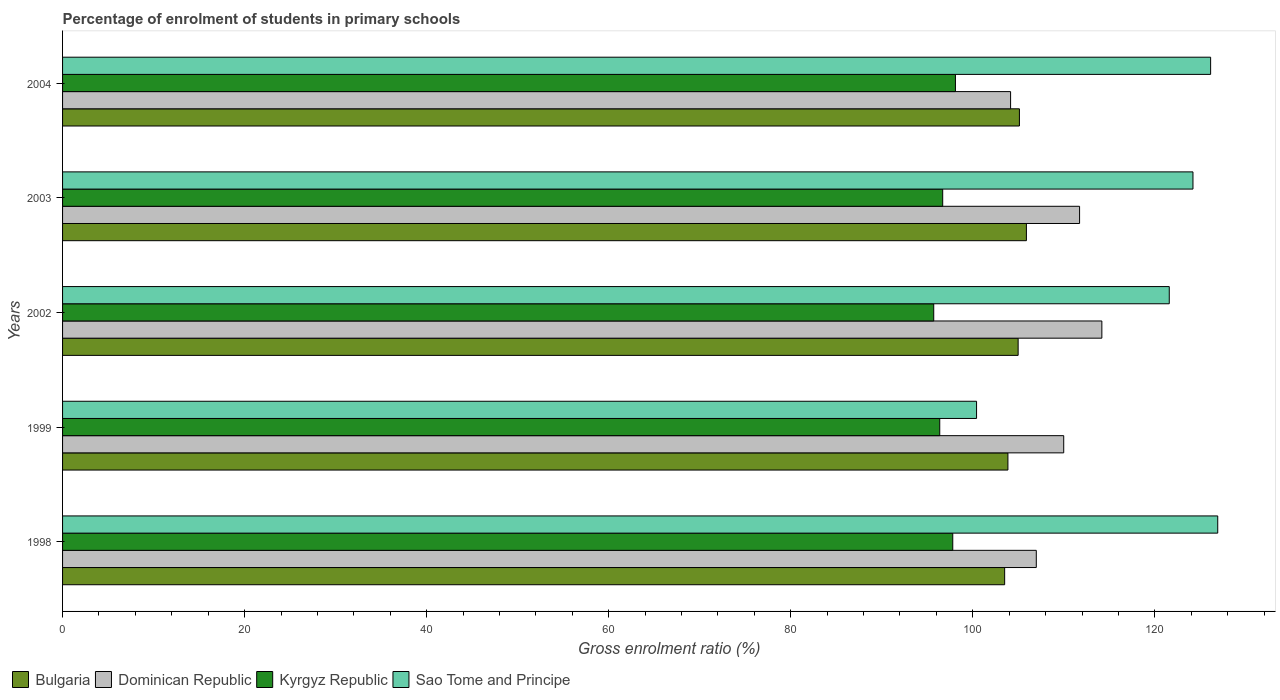Are the number of bars per tick equal to the number of legend labels?
Offer a very short reply. Yes. How many bars are there on the 5th tick from the bottom?
Keep it short and to the point. 4. What is the label of the 4th group of bars from the top?
Your response must be concise. 1999. In how many cases, is the number of bars for a given year not equal to the number of legend labels?
Offer a terse response. 0. What is the percentage of students enrolled in primary schools in Kyrgyz Republic in 1998?
Make the answer very short. 97.8. Across all years, what is the maximum percentage of students enrolled in primary schools in Sao Tome and Principe?
Give a very brief answer. 126.91. Across all years, what is the minimum percentage of students enrolled in primary schools in Dominican Republic?
Make the answer very short. 104.15. In which year was the percentage of students enrolled in primary schools in Sao Tome and Principe maximum?
Offer a very short reply. 1998. In which year was the percentage of students enrolled in primary schools in Dominican Republic minimum?
Offer a very short reply. 2004. What is the total percentage of students enrolled in primary schools in Sao Tome and Principe in the graph?
Your answer should be compact. 599.22. What is the difference between the percentage of students enrolled in primary schools in Dominican Republic in 1998 and that in 1999?
Offer a very short reply. -3.01. What is the difference between the percentage of students enrolled in primary schools in Bulgaria in 2004 and the percentage of students enrolled in primary schools in Dominican Republic in 1999?
Give a very brief answer. -4.87. What is the average percentage of students enrolled in primary schools in Sao Tome and Principe per year?
Keep it short and to the point. 119.84. In the year 1999, what is the difference between the percentage of students enrolled in primary schools in Dominican Republic and percentage of students enrolled in primary schools in Bulgaria?
Offer a terse response. 6.13. In how many years, is the percentage of students enrolled in primary schools in Kyrgyz Republic greater than 44 %?
Offer a very short reply. 5. What is the ratio of the percentage of students enrolled in primary schools in Bulgaria in 2002 to that in 2003?
Your answer should be very brief. 0.99. Is the difference between the percentage of students enrolled in primary schools in Dominican Republic in 2003 and 2004 greater than the difference between the percentage of students enrolled in primary schools in Bulgaria in 2003 and 2004?
Ensure brevity in your answer.  Yes. What is the difference between the highest and the second highest percentage of students enrolled in primary schools in Kyrgyz Republic?
Provide a short and direct response. 0.29. What is the difference between the highest and the lowest percentage of students enrolled in primary schools in Sao Tome and Principe?
Ensure brevity in your answer.  26.49. In how many years, is the percentage of students enrolled in primary schools in Kyrgyz Republic greater than the average percentage of students enrolled in primary schools in Kyrgyz Republic taken over all years?
Provide a succinct answer. 2. Is the sum of the percentage of students enrolled in primary schools in Dominican Republic in 1998 and 1999 greater than the maximum percentage of students enrolled in primary schools in Sao Tome and Principe across all years?
Offer a terse response. Yes. What does the 1st bar from the top in 2004 represents?
Keep it short and to the point. Sao Tome and Principe. What does the 3rd bar from the bottom in 2003 represents?
Provide a succinct answer. Kyrgyz Republic. Are all the bars in the graph horizontal?
Give a very brief answer. Yes. How many years are there in the graph?
Your response must be concise. 5. What is the difference between two consecutive major ticks on the X-axis?
Your answer should be very brief. 20. Does the graph contain grids?
Provide a succinct answer. No. Where does the legend appear in the graph?
Keep it short and to the point. Bottom left. How many legend labels are there?
Make the answer very short. 4. What is the title of the graph?
Offer a terse response. Percentage of enrolment of students in primary schools. Does "Guinea" appear as one of the legend labels in the graph?
Give a very brief answer. No. What is the Gross enrolment ratio (%) of Bulgaria in 1998?
Keep it short and to the point. 103.5. What is the Gross enrolment ratio (%) in Dominican Republic in 1998?
Make the answer very short. 106.98. What is the Gross enrolment ratio (%) in Kyrgyz Republic in 1998?
Your answer should be very brief. 97.8. What is the Gross enrolment ratio (%) of Sao Tome and Principe in 1998?
Your answer should be compact. 126.91. What is the Gross enrolment ratio (%) in Bulgaria in 1999?
Offer a very short reply. 103.86. What is the Gross enrolment ratio (%) in Dominican Republic in 1999?
Your response must be concise. 109.99. What is the Gross enrolment ratio (%) of Kyrgyz Republic in 1999?
Give a very brief answer. 96.37. What is the Gross enrolment ratio (%) of Sao Tome and Principe in 1999?
Keep it short and to the point. 100.41. What is the Gross enrolment ratio (%) in Bulgaria in 2002?
Offer a very short reply. 104.98. What is the Gross enrolment ratio (%) in Dominican Republic in 2002?
Your answer should be very brief. 114.18. What is the Gross enrolment ratio (%) in Kyrgyz Republic in 2002?
Your response must be concise. 95.71. What is the Gross enrolment ratio (%) in Sao Tome and Principe in 2002?
Give a very brief answer. 121.58. What is the Gross enrolment ratio (%) in Bulgaria in 2003?
Make the answer very short. 105.89. What is the Gross enrolment ratio (%) in Dominican Republic in 2003?
Keep it short and to the point. 111.73. What is the Gross enrolment ratio (%) of Kyrgyz Republic in 2003?
Keep it short and to the point. 96.69. What is the Gross enrolment ratio (%) in Sao Tome and Principe in 2003?
Give a very brief answer. 124.19. What is the Gross enrolment ratio (%) of Bulgaria in 2004?
Provide a short and direct response. 105.12. What is the Gross enrolment ratio (%) in Dominican Republic in 2004?
Your response must be concise. 104.15. What is the Gross enrolment ratio (%) in Kyrgyz Republic in 2004?
Ensure brevity in your answer.  98.09. What is the Gross enrolment ratio (%) in Sao Tome and Principe in 2004?
Your answer should be very brief. 126.13. Across all years, what is the maximum Gross enrolment ratio (%) of Bulgaria?
Offer a very short reply. 105.89. Across all years, what is the maximum Gross enrolment ratio (%) in Dominican Republic?
Provide a short and direct response. 114.18. Across all years, what is the maximum Gross enrolment ratio (%) of Kyrgyz Republic?
Your response must be concise. 98.09. Across all years, what is the maximum Gross enrolment ratio (%) in Sao Tome and Principe?
Ensure brevity in your answer.  126.91. Across all years, what is the minimum Gross enrolment ratio (%) in Bulgaria?
Offer a terse response. 103.5. Across all years, what is the minimum Gross enrolment ratio (%) in Dominican Republic?
Provide a succinct answer. 104.15. Across all years, what is the minimum Gross enrolment ratio (%) in Kyrgyz Republic?
Give a very brief answer. 95.71. Across all years, what is the minimum Gross enrolment ratio (%) of Sao Tome and Principe?
Give a very brief answer. 100.41. What is the total Gross enrolment ratio (%) in Bulgaria in the graph?
Your answer should be compact. 523.35. What is the total Gross enrolment ratio (%) in Dominican Republic in the graph?
Ensure brevity in your answer.  547.03. What is the total Gross enrolment ratio (%) in Kyrgyz Republic in the graph?
Offer a terse response. 484.66. What is the total Gross enrolment ratio (%) of Sao Tome and Principe in the graph?
Give a very brief answer. 599.22. What is the difference between the Gross enrolment ratio (%) of Bulgaria in 1998 and that in 1999?
Keep it short and to the point. -0.36. What is the difference between the Gross enrolment ratio (%) in Dominican Republic in 1998 and that in 1999?
Give a very brief answer. -3.01. What is the difference between the Gross enrolment ratio (%) of Kyrgyz Republic in 1998 and that in 1999?
Give a very brief answer. 1.43. What is the difference between the Gross enrolment ratio (%) in Sao Tome and Principe in 1998 and that in 1999?
Ensure brevity in your answer.  26.5. What is the difference between the Gross enrolment ratio (%) of Bulgaria in 1998 and that in 2002?
Your answer should be very brief. -1.48. What is the difference between the Gross enrolment ratio (%) of Dominican Republic in 1998 and that in 2002?
Your answer should be very brief. -7.2. What is the difference between the Gross enrolment ratio (%) of Kyrgyz Republic in 1998 and that in 2002?
Your answer should be compact. 2.09. What is the difference between the Gross enrolment ratio (%) of Sao Tome and Principe in 1998 and that in 2002?
Offer a very short reply. 5.33. What is the difference between the Gross enrolment ratio (%) of Bulgaria in 1998 and that in 2003?
Make the answer very short. -2.39. What is the difference between the Gross enrolment ratio (%) of Dominican Republic in 1998 and that in 2003?
Provide a succinct answer. -4.75. What is the difference between the Gross enrolment ratio (%) in Kyrgyz Republic in 1998 and that in 2003?
Provide a succinct answer. 1.11. What is the difference between the Gross enrolment ratio (%) in Sao Tome and Principe in 1998 and that in 2003?
Offer a terse response. 2.72. What is the difference between the Gross enrolment ratio (%) of Bulgaria in 1998 and that in 2004?
Offer a terse response. -1.62. What is the difference between the Gross enrolment ratio (%) in Dominican Republic in 1998 and that in 2004?
Ensure brevity in your answer.  2.82. What is the difference between the Gross enrolment ratio (%) in Kyrgyz Republic in 1998 and that in 2004?
Make the answer very short. -0.29. What is the difference between the Gross enrolment ratio (%) of Sao Tome and Principe in 1998 and that in 2004?
Provide a short and direct response. 0.78. What is the difference between the Gross enrolment ratio (%) of Bulgaria in 1999 and that in 2002?
Your answer should be compact. -1.12. What is the difference between the Gross enrolment ratio (%) of Dominican Republic in 1999 and that in 2002?
Offer a terse response. -4.19. What is the difference between the Gross enrolment ratio (%) in Kyrgyz Republic in 1999 and that in 2002?
Make the answer very short. 0.66. What is the difference between the Gross enrolment ratio (%) in Sao Tome and Principe in 1999 and that in 2002?
Your answer should be very brief. -21.17. What is the difference between the Gross enrolment ratio (%) in Bulgaria in 1999 and that in 2003?
Offer a very short reply. -2.03. What is the difference between the Gross enrolment ratio (%) of Dominican Republic in 1999 and that in 2003?
Your answer should be compact. -1.74. What is the difference between the Gross enrolment ratio (%) in Kyrgyz Republic in 1999 and that in 2003?
Provide a short and direct response. -0.32. What is the difference between the Gross enrolment ratio (%) of Sao Tome and Principe in 1999 and that in 2003?
Your response must be concise. -23.77. What is the difference between the Gross enrolment ratio (%) in Bulgaria in 1999 and that in 2004?
Offer a terse response. -1.26. What is the difference between the Gross enrolment ratio (%) of Dominican Republic in 1999 and that in 2004?
Provide a succinct answer. 5.84. What is the difference between the Gross enrolment ratio (%) of Kyrgyz Republic in 1999 and that in 2004?
Your answer should be compact. -1.72. What is the difference between the Gross enrolment ratio (%) in Sao Tome and Principe in 1999 and that in 2004?
Your answer should be very brief. -25.71. What is the difference between the Gross enrolment ratio (%) in Bulgaria in 2002 and that in 2003?
Your response must be concise. -0.91. What is the difference between the Gross enrolment ratio (%) of Dominican Republic in 2002 and that in 2003?
Provide a short and direct response. 2.45. What is the difference between the Gross enrolment ratio (%) in Kyrgyz Republic in 2002 and that in 2003?
Ensure brevity in your answer.  -0.99. What is the difference between the Gross enrolment ratio (%) of Sao Tome and Principe in 2002 and that in 2003?
Offer a terse response. -2.61. What is the difference between the Gross enrolment ratio (%) in Bulgaria in 2002 and that in 2004?
Your answer should be very brief. -0.14. What is the difference between the Gross enrolment ratio (%) in Dominican Republic in 2002 and that in 2004?
Provide a short and direct response. 10.03. What is the difference between the Gross enrolment ratio (%) in Kyrgyz Republic in 2002 and that in 2004?
Ensure brevity in your answer.  -2.39. What is the difference between the Gross enrolment ratio (%) of Sao Tome and Principe in 2002 and that in 2004?
Make the answer very short. -4.55. What is the difference between the Gross enrolment ratio (%) in Bulgaria in 2003 and that in 2004?
Give a very brief answer. 0.77. What is the difference between the Gross enrolment ratio (%) in Dominican Republic in 2003 and that in 2004?
Provide a succinct answer. 7.58. What is the difference between the Gross enrolment ratio (%) of Kyrgyz Republic in 2003 and that in 2004?
Provide a succinct answer. -1.4. What is the difference between the Gross enrolment ratio (%) in Sao Tome and Principe in 2003 and that in 2004?
Your response must be concise. -1.94. What is the difference between the Gross enrolment ratio (%) in Bulgaria in 1998 and the Gross enrolment ratio (%) in Dominican Republic in 1999?
Provide a succinct answer. -6.49. What is the difference between the Gross enrolment ratio (%) in Bulgaria in 1998 and the Gross enrolment ratio (%) in Kyrgyz Republic in 1999?
Make the answer very short. 7.13. What is the difference between the Gross enrolment ratio (%) of Bulgaria in 1998 and the Gross enrolment ratio (%) of Sao Tome and Principe in 1999?
Provide a short and direct response. 3.09. What is the difference between the Gross enrolment ratio (%) of Dominican Republic in 1998 and the Gross enrolment ratio (%) of Kyrgyz Republic in 1999?
Keep it short and to the point. 10.61. What is the difference between the Gross enrolment ratio (%) in Dominican Republic in 1998 and the Gross enrolment ratio (%) in Sao Tome and Principe in 1999?
Your answer should be very brief. 6.56. What is the difference between the Gross enrolment ratio (%) in Kyrgyz Republic in 1998 and the Gross enrolment ratio (%) in Sao Tome and Principe in 1999?
Your answer should be very brief. -2.61. What is the difference between the Gross enrolment ratio (%) of Bulgaria in 1998 and the Gross enrolment ratio (%) of Dominican Republic in 2002?
Keep it short and to the point. -10.68. What is the difference between the Gross enrolment ratio (%) in Bulgaria in 1998 and the Gross enrolment ratio (%) in Kyrgyz Republic in 2002?
Offer a very short reply. 7.79. What is the difference between the Gross enrolment ratio (%) in Bulgaria in 1998 and the Gross enrolment ratio (%) in Sao Tome and Principe in 2002?
Keep it short and to the point. -18.08. What is the difference between the Gross enrolment ratio (%) of Dominican Republic in 1998 and the Gross enrolment ratio (%) of Kyrgyz Republic in 2002?
Make the answer very short. 11.27. What is the difference between the Gross enrolment ratio (%) in Dominican Republic in 1998 and the Gross enrolment ratio (%) in Sao Tome and Principe in 2002?
Provide a succinct answer. -14.61. What is the difference between the Gross enrolment ratio (%) in Kyrgyz Republic in 1998 and the Gross enrolment ratio (%) in Sao Tome and Principe in 2002?
Keep it short and to the point. -23.78. What is the difference between the Gross enrolment ratio (%) in Bulgaria in 1998 and the Gross enrolment ratio (%) in Dominican Republic in 2003?
Provide a succinct answer. -8.23. What is the difference between the Gross enrolment ratio (%) in Bulgaria in 1998 and the Gross enrolment ratio (%) in Kyrgyz Republic in 2003?
Provide a succinct answer. 6.81. What is the difference between the Gross enrolment ratio (%) of Bulgaria in 1998 and the Gross enrolment ratio (%) of Sao Tome and Principe in 2003?
Make the answer very short. -20.69. What is the difference between the Gross enrolment ratio (%) of Dominican Republic in 1998 and the Gross enrolment ratio (%) of Kyrgyz Republic in 2003?
Make the answer very short. 10.28. What is the difference between the Gross enrolment ratio (%) of Dominican Republic in 1998 and the Gross enrolment ratio (%) of Sao Tome and Principe in 2003?
Provide a succinct answer. -17.21. What is the difference between the Gross enrolment ratio (%) of Kyrgyz Republic in 1998 and the Gross enrolment ratio (%) of Sao Tome and Principe in 2003?
Your answer should be very brief. -26.39. What is the difference between the Gross enrolment ratio (%) of Bulgaria in 1998 and the Gross enrolment ratio (%) of Dominican Republic in 2004?
Your answer should be very brief. -0.65. What is the difference between the Gross enrolment ratio (%) of Bulgaria in 1998 and the Gross enrolment ratio (%) of Kyrgyz Republic in 2004?
Make the answer very short. 5.41. What is the difference between the Gross enrolment ratio (%) in Bulgaria in 1998 and the Gross enrolment ratio (%) in Sao Tome and Principe in 2004?
Offer a very short reply. -22.63. What is the difference between the Gross enrolment ratio (%) in Dominican Republic in 1998 and the Gross enrolment ratio (%) in Kyrgyz Republic in 2004?
Provide a short and direct response. 8.88. What is the difference between the Gross enrolment ratio (%) of Dominican Republic in 1998 and the Gross enrolment ratio (%) of Sao Tome and Principe in 2004?
Provide a short and direct response. -19.15. What is the difference between the Gross enrolment ratio (%) in Kyrgyz Republic in 1998 and the Gross enrolment ratio (%) in Sao Tome and Principe in 2004?
Your response must be concise. -28.33. What is the difference between the Gross enrolment ratio (%) in Bulgaria in 1999 and the Gross enrolment ratio (%) in Dominican Republic in 2002?
Ensure brevity in your answer.  -10.32. What is the difference between the Gross enrolment ratio (%) in Bulgaria in 1999 and the Gross enrolment ratio (%) in Kyrgyz Republic in 2002?
Offer a terse response. 8.15. What is the difference between the Gross enrolment ratio (%) of Bulgaria in 1999 and the Gross enrolment ratio (%) of Sao Tome and Principe in 2002?
Your answer should be compact. -17.72. What is the difference between the Gross enrolment ratio (%) in Dominican Republic in 1999 and the Gross enrolment ratio (%) in Kyrgyz Republic in 2002?
Give a very brief answer. 14.28. What is the difference between the Gross enrolment ratio (%) in Dominican Republic in 1999 and the Gross enrolment ratio (%) in Sao Tome and Principe in 2002?
Offer a very short reply. -11.6. What is the difference between the Gross enrolment ratio (%) in Kyrgyz Republic in 1999 and the Gross enrolment ratio (%) in Sao Tome and Principe in 2002?
Provide a short and direct response. -25.21. What is the difference between the Gross enrolment ratio (%) of Bulgaria in 1999 and the Gross enrolment ratio (%) of Dominican Republic in 2003?
Keep it short and to the point. -7.87. What is the difference between the Gross enrolment ratio (%) of Bulgaria in 1999 and the Gross enrolment ratio (%) of Kyrgyz Republic in 2003?
Provide a short and direct response. 7.17. What is the difference between the Gross enrolment ratio (%) of Bulgaria in 1999 and the Gross enrolment ratio (%) of Sao Tome and Principe in 2003?
Your answer should be compact. -20.33. What is the difference between the Gross enrolment ratio (%) of Dominican Republic in 1999 and the Gross enrolment ratio (%) of Kyrgyz Republic in 2003?
Keep it short and to the point. 13.29. What is the difference between the Gross enrolment ratio (%) of Dominican Republic in 1999 and the Gross enrolment ratio (%) of Sao Tome and Principe in 2003?
Your response must be concise. -14.2. What is the difference between the Gross enrolment ratio (%) of Kyrgyz Republic in 1999 and the Gross enrolment ratio (%) of Sao Tome and Principe in 2003?
Make the answer very short. -27.82. What is the difference between the Gross enrolment ratio (%) of Bulgaria in 1999 and the Gross enrolment ratio (%) of Dominican Republic in 2004?
Keep it short and to the point. -0.29. What is the difference between the Gross enrolment ratio (%) of Bulgaria in 1999 and the Gross enrolment ratio (%) of Kyrgyz Republic in 2004?
Make the answer very short. 5.77. What is the difference between the Gross enrolment ratio (%) of Bulgaria in 1999 and the Gross enrolment ratio (%) of Sao Tome and Principe in 2004?
Provide a short and direct response. -22.27. What is the difference between the Gross enrolment ratio (%) of Dominican Republic in 1999 and the Gross enrolment ratio (%) of Kyrgyz Republic in 2004?
Keep it short and to the point. 11.89. What is the difference between the Gross enrolment ratio (%) of Dominican Republic in 1999 and the Gross enrolment ratio (%) of Sao Tome and Principe in 2004?
Your response must be concise. -16.14. What is the difference between the Gross enrolment ratio (%) in Kyrgyz Republic in 1999 and the Gross enrolment ratio (%) in Sao Tome and Principe in 2004?
Provide a short and direct response. -29.76. What is the difference between the Gross enrolment ratio (%) in Bulgaria in 2002 and the Gross enrolment ratio (%) in Dominican Republic in 2003?
Your answer should be very brief. -6.75. What is the difference between the Gross enrolment ratio (%) of Bulgaria in 2002 and the Gross enrolment ratio (%) of Kyrgyz Republic in 2003?
Keep it short and to the point. 8.29. What is the difference between the Gross enrolment ratio (%) of Bulgaria in 2002 and the Gross enrolment ratio (%) of Sao Tome and Principe in 2003?
Provide a succinct answer. -19.21. What is the difference between the Gross enrolment ratio (%) of Dominican Republic in 2002 and the Gross enrolment ratio (%) of Kyrgyz Republic in 2003?
Keep it short and to the point. 17.49. What is the difference between the Gross enrolment ratio (%) of Dominican Republic in 2002 and the Gross enrolment ratio (%) of Sao Tome and Principe in 2003?
Your answer should be compact. -10.01. What is the difference between the Gross enrolment ratio (%) in Kyrgyz Republic in 2002 and the Gross enrolment ratio (%) in Sao Tome and Principe in 2003?
Offer a terse response. -28.48. What is the difference between the Gross enrolment ratio (%) in Bulgaria in 2002 and the Gross enrolment ratio (%) in Dominican Republic in 2004?
Offer a very short reply. 0.83. What is the difference between the Gross enrolment ratio (%) of Bulgaria in 2002 and the Gross enrolment ratio (%) of Kyrgyz Republic in 2004?
Offer a very short reply. 6.89. What is the difference between the Gross enrolment ratio (%) of Bulgaria in 2002 and the Gross enrolment ratio (%) of Sao Tome and Principe in 2004?
Give a very brief answer. -21.15. What is the difference between the Gross enrolment ratio (%) in Dominican Republic in 2002 and the Gross enrolment ratio (%) in Kyrgyz Republic in 2004?
Your answer should be compact. 16.09. What is the difference between the Gross enrolment ratio (%) of Dominican Republic in 2002 and the Gross enrolment ratio (%) of Sao Tome and Principe in 2004?
Keep it short and to the point. -11.95. What is the difference between the Gross enrolment ratio (%) in Kyrgyz Republic in 2002 and the Gross enrolment ratio (%) in Sao Tome and Principe in 2004?
Your answer should be compact. -30.42. What is the difference between the Gross enrolment ratio (%) in Bulgaria in 2003 and the Gross enrolment ratio (%) in Dominican Republic in 2004?
Provide a succinct answer. 1.74. What is the difference between the Gross enrolment ratio (%) in Bulgaria in 2003 and the Gross enrolment ratio (%) in Kyrgyz Republic in 2004?
Keep it short and to the point. 7.8. What is the difference between the Gross enrolment ratio (%) in Bulgaria in 2003 and the Gross enrolment ratio (%) in Sao Tome and Principe in 2004?
Give a very brief answer. -20.24. What is the difference between the Gross enrolment ratio (%) of Dominican Republic in 2003 and the Gross enrolment ratio (%) of Kyrgyz Republic in 2004?
Make the answer very short. 13.64. What is the difference between the Gross enrolment ratio (%) of Dominican Republic in 2003 and the Gross enrolment ratio (%) of Sao Tome and Principe in 2004?
Provide a succinct answer. -14.4. What is the difference between the Gross enrolment ratio (%) of Kyrgyz Republic in 2003 and the Gross enrolment ratio (%) of Sao Tome and Principe in 2004?
Your response must be concise. -29.44. What is the average Gross enrolment ratio (%) of Bulgaria per year?
Make the answer very short. 104.67. What is the average Gross enrolment ratio (%) in Dominican Republic per year?
Your answer should be compact. 109.41. What is the average Gross enrolment ratio (%) of Kyrgyz Republic per year?
Keep it short and to the point. 96.93. What is the average Gross enrolment ratio (%) of Sao Tome and Principe per year?
Provide a short and direct response. 119.84. In the year 1998, what is the difference between the Gross enrolment ratio (%) of Bulgaria and Gross enrolment ratio (%) of Dominican Republic?
Provide a short and direct response. -3.48. In the year 1998, what is the difference between the Gross enrolment ratio (%) of Bulgaria and Gross enrolment ratio (%) of Kyrgyz Republic?
Your answer should be very brief. 5.7. In the year 1998, what is the difference between the Gross enrolment ratio (%) of Bulgaria and Gross enrolment ratio (%) of Sao Tome and Principe?
Your response must be concise. -23.41. In the year 1998, what is the difference between the Gross enrolment ratio (%) in Dominican Republic and Gross enrolment ratio (%) in Kyrgyz Republic?
Offer a very short reply. 9.18. In the year 1998, what is the difference between the Gross enrolment ratio (%) of Dominican Republic and Gross enrolment ratio (%) of Sao Tome and Principe?
Provide a short and direct response. -19.93. In the year 1998, what is the difference between the Gross enrolment ratio (%) in Kyrgyz Republic and Gross enrolment ratio (%) in Sao Tome and Principe?
Provide a succinct answer. -29.11. In the year 1999, what is the difference between the Gross enrolment ratio (%) of Bulgaria and Gross enrolment ratio (%) of Dominican Republic?
Make the answer very short. -6.13. In the year 1999, what is the difference between the Gross enrolment ratio (%) of Bulgaria and Gross enrolment ratio (%) of Kyrgyz Republic?
Provide a short and direct response. 7.49. In the year 1999, what is the difference between the Gross enrolment ratio (%) of Bulgaria and Gross enrolment ratio (%) of Sao Tome and Principe?
Ensure brevity in your answer.  3.45. In the year 1999, what is the difference between the Gross enrolment ratio (%) of Dominican Republic and Gross enrolment ratio (%) of Kyrgyz Republic?
Ensure brevity in your answer.  13.62. In the year 1999, what is the difference between the Gross enrolment ratio (%) in Dominican Republic and Gross enrolment ratio (%) in Sao Tome and Principe?
Make the answer very short. 9.57. In the year 1999, what is the difference between the Gross enrolment ratio (%) of Kyrgyz Republic and Gross enrolment ratio (%) of Sao Tome and Principe?
Offer a terse response. -4.04. In the year 2002, what is the difference between the Gross enrolment ratio (%) in Bulgaria and Gross enrolment ratio (%) in Dominican Republic?
Ensure brevity in your answer.  -9.2. In the year 2002, what is the difference between the Gross enrolment ratio (%) in Bulgaria and Gross enrolment ratio (%) in Kyrgyz Republic?
Your answer should be compact. 9.27. In the year 2002, what is the difference between the Gross enrolment ratio (%) of Bulgaria and Gross enrolment ratio (%) of Sao Tome and Principe?
Provide a short and direct response. -16.6. In the year 2002, what is the difference between the Gross enrolment ratio (%) of Dominican Republic and Gross enrolment ratio (%) of Kyrgyz Republic?
Give a very brief answer. 18.47. In the year 2002, what is the difference between the Gross enrolment ratio (%) of Dominican Republic and Gross enrolment ratio (%) of Sao Tome and Principe?
Offer a terse response. -7.4. In the year 2002, what is the difference between the Gross enrolment ratio (%) of Kyrgyz Republic and Gross enrolment ratio (%) of Sao Tome and Principe?
Offer a terse response. -25.88. In the year 2003, what is the difference between the Gross enrolment ratio (%) of Bulgaria and Gross enrolment ratio (%) of Dominican Republic?
Provide a short and direct response. -5.84. In the year 2003, what is the difference between the Gross enrolment ratio (%) in Bulgaria and Gross enrolment ratio (%) in Kyrgyz Republic?
Offer a terse response. 9.2. In the year 2003, what is the difference between the Gross enrolment ratio (%) of Bulgaria and Gross enrolment ratio (%) of Sao Tome and Principe?
Your answer should be very brief. -18.3. In the year 2003, what is the difference between the Gross enrolment ratio (%) in Dominican Republic and Gross enrolment ratio (%) in Kyrgyz Republic?
Ensure brevity in your answer.  15.04. In the year 2003, what is the difference between the Gross enrolment ratio (%) in Dominican Republic and Gross enrolment ratio (%) in Sao Tome and Principe?
Offer a very short reply. -12.46. In the year 2003, what is the difference between the Gross enrolment ratio (%) of Kyrgyz Republic and Gross enrolment ratio (%) of Sao Tome and Principe?
Keep it short and to the point. -27.5. In the year 2004, what is the difference between the Gross enrolment ratio (%) of Bulgaria and Gross enrolment ratio (%) of Dominican Republic?
Ensure brevity in your answer.  0.97. In the year 2004, what is the difference between the Gross enrolment ratio (%) in Bulgaria and Gross enrolment ratio (%) in Kyrgyz Republic?
Provide a succinct answer. 7.03. In the year 2004, what is the difference between the Gross enrolment ratio (%) in Bulgaria and Gross enrolment ratio (%) in Sao Tome and Principe?
Make the answer very short. -21.01. In the year 2004, what is the difference between the Gross enrolment ratio (%) in Dominican Republic and Gross enrolment ratio (%) in Kyrgyz Republic?
Your response must be concise. 6.06. In the year 2004, what is the difference between the Gross enrolment ratio (%) of Dominican Republic and Gross enrolment ratio (%) of Sao Tome and Principe?
Your answer should be compact. -21.98. In the year 2004, what is the difference between the Gross enrolment ratio (%) of Kyrgyz Republic and Gross enrolment ratio (%) of Sao Tome and Principe?
Ensure brevity in your answer.  -28.04. What is the ratio of the Gross enrolment ratio (%) of Bulgaria in 1998 to that in 1999?
Offer a terse response. 1. What is the ratio of the Gross enrolment ratio (%) of Dominican Republic in 1998 to that in 1999?
Keep it short and to the point. 0.97. What is the ratio of the Gross enrolment ratio (%) in Kyrgyz Republic in 1998 to that in 1999?
Your answer should be compact. 1.01. What is the ratio of the Gross enrolment ratio (%) in Sao Tome and Principe in 1998 to that in 1999?
Ensure brevity in your answer.  1.26. What is the ratio of the Gross enrolment ratio (%) of Bulgaria in 1998 to that in 2002?
Your answer should be compact. 0.99. What is the ratio of the Gross enrolment ratio (%) of Dominican Republic in 1998 to that in 2002?
Give a very brief answer. 0.94. What is the ratio of the Gross enrolment ratio (%) in Kyrgyz Republic in 1998 to that in 2002?
Provide a short and direct response. 1.02. What is the ratio of the Gross enrolment ratio (%) in Sao Tome and Principe in 1998 to that in 2002?
Provide a short and direct response. 1.04. What is the ratio of the Gross enrolment ratio (%) of Bulgaria in 1998 to that in 2003?
Offer a terse response. 0.98. What is the ratio of the Gross enrolment ratio (%) of Dominican Republic in 1998 to that in 2003?
Provide a short and direct response. 0.96. What is the ratio of the Gross enrolment ratio (%) of Kyrgyz Republic in 1998 to that in 2003?
Your response must be concise. 1.01. What is the ratio of the Gross enrolment ratio (%) of Sao Tome and Principe in 1998 to that in 2003?
Make the answer very short. 1.02. What is the ratio of the Gross enrolment ratio (%) of Bulgaria in 1998 to that in 2004?
Ensure brevity in your answer.  0.98. What is the ratio of the Gross enrolment ratio (%) in Dominican Republic in 1998 to that in 2004?
Give a very brief answer. 1.03. What is the ratio of the Gross enrolment ratio (%) in Kyrgyz Republic in 1998 to that in 2004?
Keep it short and to the point. 1. What is the ratio of the Gross enrolment ratio (%) in Sao Tome and Principe in 1998 to that in 2004?
Offer a terse response. 1.01. What is the ratio of the Gross enrolment ratio (%) of Bulgaria in 1999 to that in 2002?
Keep it short and to the point. 0.99. What is the ratio of the Gross enrolment ratio (%) of Dominican Republic in 1999 to that in 2002?
Keep it short and to the point. 0.96. What is the ratio of the Gross enrolment ratio (%) in Sao Tome and Principe in 1999 to that in 2002?
Keep it short and to the point. 0.83. What is the ratio of the Gross enrolment ratio (%) in Bulgaria in 1999 to that in 2003?
Make the answer very short. 0.98. What is the ratio of the Gross enrolment ratio (%) of Dominican Republic in 1999 to that in 2003?
Keep it short and to the point. 0.98. What is the ratio of the Gross enrolment ratio (%) in Kyrgyz Republic in 1999 to that in 2003?
Your response must be concise. 1. What is the ratio of the Gross enrolment ratio (%) in Sao Tome and Principe in 1999 to that in 2003?
Keep it short and to the point. 0.81. What is the ratio of the Gross enrolment ratio (%) in Bulgaria in 1999 to that in 2004?
Give a very brief answer. 0.99. What is the ratio of the Gross enrolment ratio (%) in Dominican Republic in 1999 to that in 2004?
Your response must be concise. 1.06. What is the ratio of the Gross enrolment ratio (%) in Kyrgyz Republic in 1999 to that in 2004?
Keep it short and to the point. 0.98. What is the ratio of the Gross enrolment ratio (%) of Sao Tome and Principe in 1999 to that in 2004?
Offer a very short reply. 0.8. What is the ratio of the Gross enrolment ratio (%) of Dominican Republic in 2002 to that in 2003?
Your response must be concise. 1.02. What is the ratio of the Gross enrolment ratio (%) of Kyrgyz Republic in 2002 to that in 2003?
Give a very brief answer. 0.99. What is the ratio of the Gross enrolment ratio (%) in Bulgaria in 2002 to that in 2004?
Keep it short and to the point. 1. What is the ratio of the Gross enrolment ratio (%) in Dominican Republic in 2002 to that in 2004?
Offer a very short reply. 1.1. What is the ratio of the Gross enrolment ratio (%) in Kyrgyz Republic in 2002 to that in 2004?
Your answer should be compact. 0.98. What is the ratio of the Gross enrolment ratio (%) of Bulgaria in 2003 to that in 2004?
Keep it short and to the point. 1.01. What is the ratio of the Gross enrolment ratio (%) in Dominican Republic in 2003 to that in 2004?
Provide a succinct answer. 1.07. What is the ratio of the Gross enrolment ratio (%) of Kyrgyz Republic in 2003 to that in 2004?
Your response must be concise. 0.99. What is the ratio of the Gross enrolment ratio (%) in Sao Tome and Principe in 2003 to that in 2004?
Your answer should be very brief. 0.98. What is the difference between the highest and the second highest Gross enrolment ratio (%) of Bulgaria?
Provide a succinct answer. 0.77. What is the difference between the highest and the second highest Gross enrolment ratio (%) in Dominican Republic?
Your response must be concise. 2.45. What is the difference between the highest and the second highest Gross enrolment ratio (%) of Kyrgyz Republic?
Provide a succinct answer. 0.29. What is the difference between the highest and the second highest Gross enrolment ratio (%) in Sao Tome and Principe?
Keep it short and to the point. 0.78. What is the difference between the highest and the lowest Gross enrolment ratio (%) in Bulgaria?
Ensure brevity in your answer.  2.39. What is the difference between the highest and the lowest Gross enrolment ratio (%) of Dominican Republic?
Your answer should be very brief. 10.03. What is the difference between the highest and the lowest Gross enrolment ratio (%) of Kyrgyz Republic?
Give a very brief answer. 2.39. What is the difference between the highest and the lowest Gross enrolment ratio (%) of Sao Tome and Principe?
Ensure brevity in your answer.  26.5. 